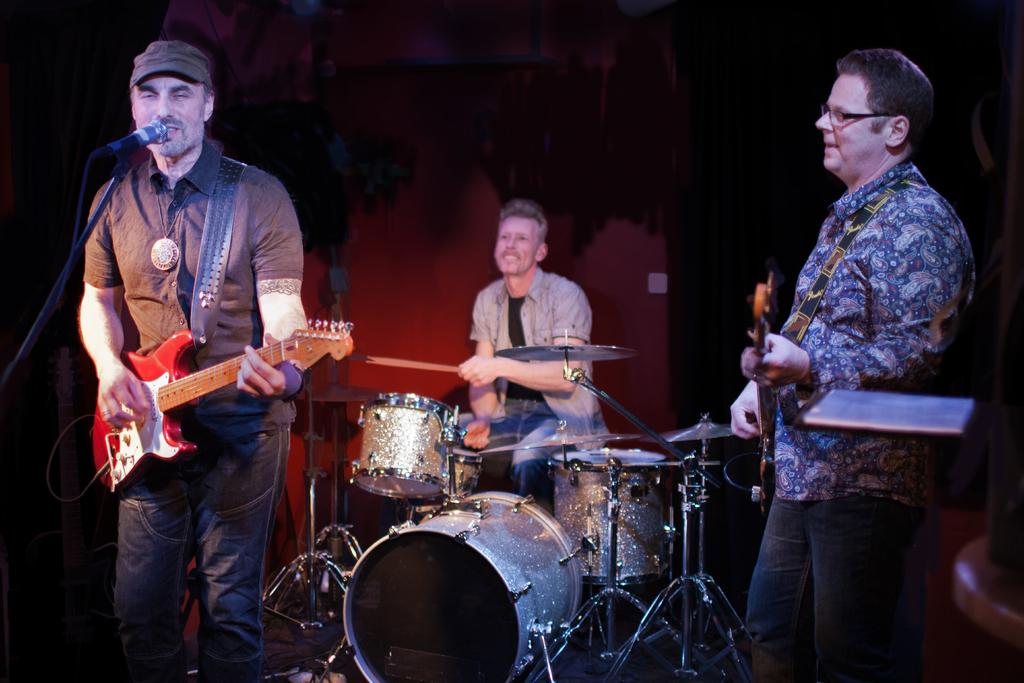How many men are present in the image? There are three men in the image. What are the two standing men holding? The two standing men are holding music instruments. What is the sitting man doing in the image? The sitting man is playing a music instrument. What is the man with the microphone doing in the image? The man with the microphone is singing. What type of structure is visible in the man's stomach in the image? There is no structure visible in any man's stomach in the image. What type of apparel is the man wearing while playing the music instrument? The provided facts do not mention any specific apparel worn by the man playing the music instrument. 